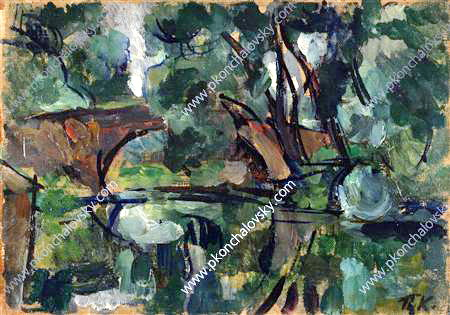What role might this landscape play in an adventure story? In an adventure story, this landscape could serve as a pivotal location where the protagonist embarks on a critical part of their journey. The serene pond, acting as a reflective mirror of fate, could be a place where they receive crucial insights or visions that guide their quest. Surrounded by an enchanted forest, the area might be teeming with magical creatures and hidden dangers, testing the hero's courage and wisdom. The tranquility of the pond may provide a rare moment of peace, a refuge where the hero can recuperate and gather strength before facing their next challenge. This mystical setting could also be the site of a hidden artifact or a portal to another world, making it an essential destination in their adventure. Who might the protagonist meet at this magical pond? At the magical pond, the protagonist might encounter a mysterious guardian—a wise, ageless being who possesses ancient knowledge and powers. This guardian could offer sage advice, cryptic warnings, or essential tools needed for the journey ahead. Alternatively, the protagonist might meet an ally, such as a skilled ranger who knows the secrets of the forest, or a mystical creature, like a talking animal or a fairy, who provides guidance and assistance. The pond could also be a meeting place for fellow adventurers with shared goals, leading to the formation of a diverse and powerful team. Each encounter at this pond would enrich the story, adding layers of intrigue, camaraderie, and magical elements to the protagonist's quest. 